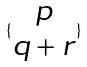<formula> <loc_0><loc_0><loc_500><loc_500>\{ \begin{matrix} p \\ q + r \end{matrix} \}</formula> 